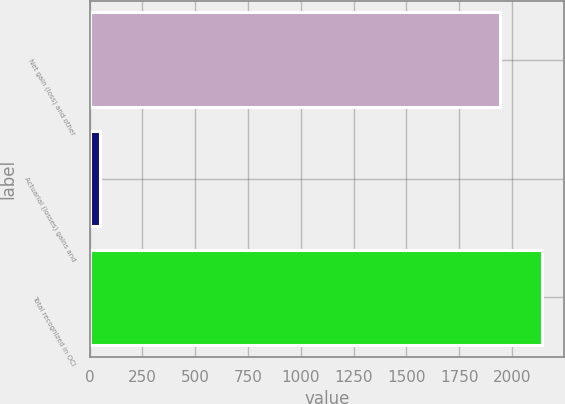<chart> <loc_0><loc_0><loc_500><loc_500><bar_chart><fcel>Net gain (loss) and other<fcel>Actuarial (losses) gains and<fcel>Total recognized in OCI<nl><fcel>1944<fcel>49<fcel>2140.1<nl></chart> 